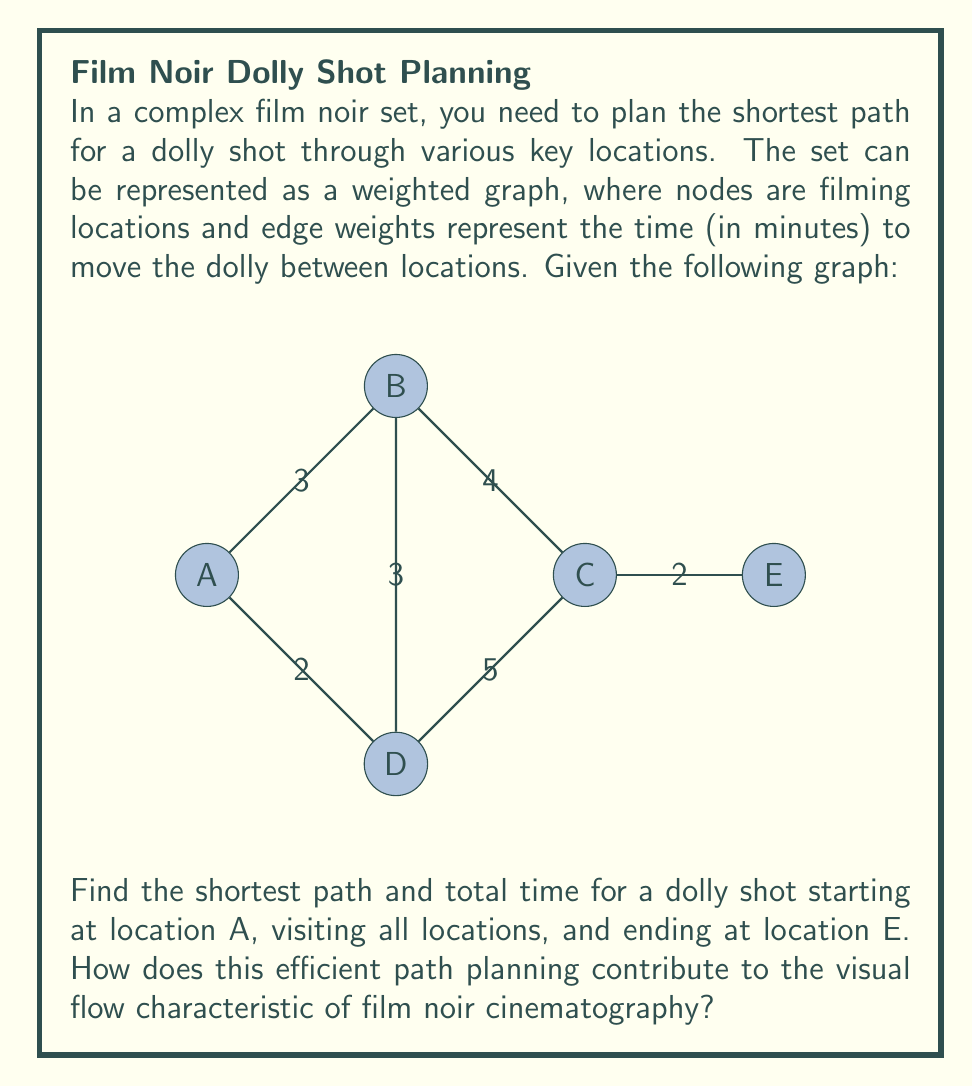Teach me how to tackle this problem. To solve this problem, we'll use Dijkstra's algorithm to find the shortest path through all nodes, starting at A and ending at E. This is essentially solving the Traveling Salesman Problem with a fixed start and end point.

Step 1: Identify all possible paths from A to E that visit all nodes.
1. A-B-C-D-E
2. A-B-D-C-E
3. A-D-B-C-E
4. A-D-C-B-E

Step 2: Calculate the total time for each path.
1. A-B-C-D-E: 3 + 4 + 5 + 2 = 14 minutes
2. A-B-D-C-E: 3 + 3 + 5 + 2 = 13 minutes
3. A-D-B-C-E: 2 + 3 + 4 + 2 = 11 minutes
4. A-D-C-B-E: 2 + 5 + 4 + 2 = 13 minutes

Step 3: Identify the shortest path.
The shortest path is A-D-B-C-E, taking 11 minutes.

This efficient path planning contributes to film noir cinematography by:
1. Enabling smooth, continuous shots that create a sense of tension and unease.
2. Allowing for complex camera movements that reveal the set's intricate details gradually.
3. Facilitating the creation of deep focus shots, a hallmark of film noir, by moving through multiple planes of action.
4. Supporting the genre's characteristic play of light and shadow by enabling carefully planned transitions between differently lit areas of the set.

The mathematical optimization of the dolly path aligns with film noir's emphasis on visual efficiency and impact, allowing filmmakers to maximize the visual storytelling within the constraints of the set and shooting schedule.
Answer: Path: A-D-B-C-E, Time: 11 minutes 